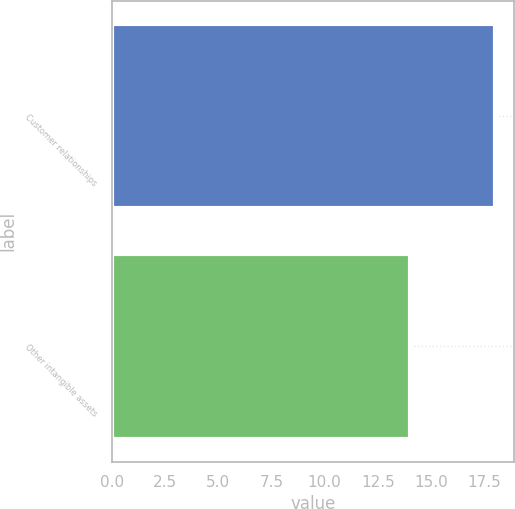Convert chart. <chart><loc_0><loc_0><loc_500><loc_500><bar_chart><fcel>Customer relationships<fcel>Other intangible assets<nl><fcel>18<fcel>14<nl></chart> 